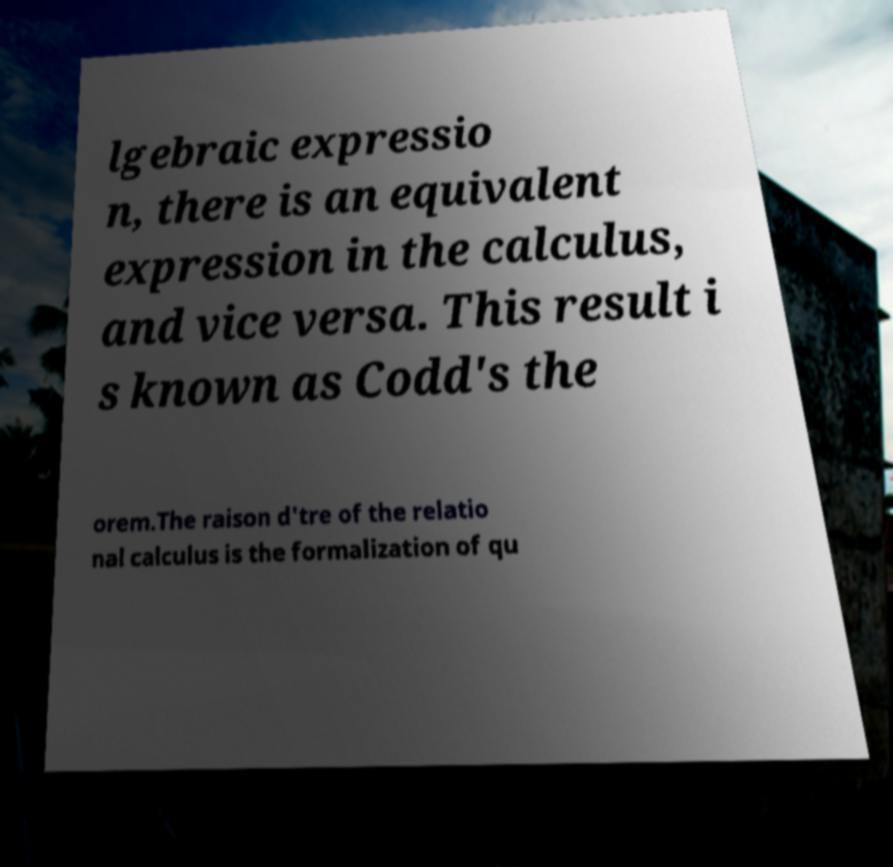What messages or text are displayed in this image? I need them in a readable, typed format. lgebraic expressio n, there is an equivalent expression in the calculus, and vice versa. This result i s known as Codd's the orem.The raison d'tre of the relatio nal calculus is the formalization of qu 